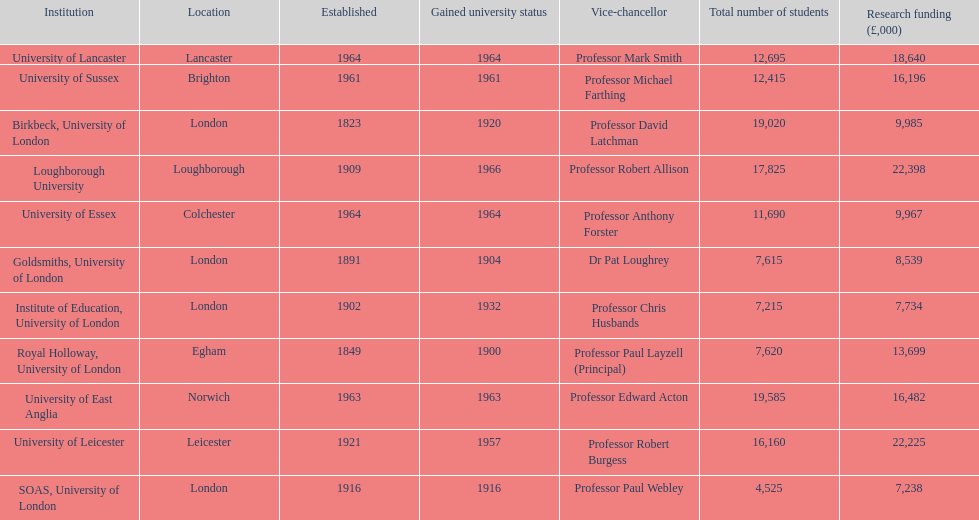How many of the institutions are located in london? 4. 